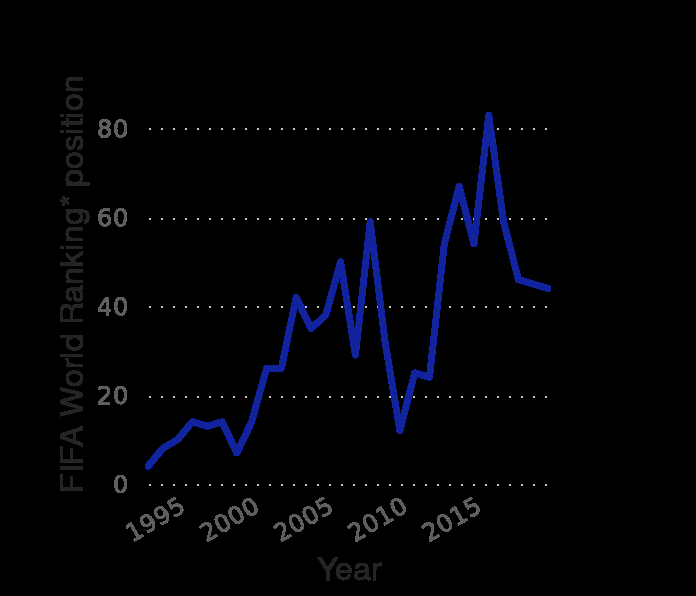<image>
In which year did the Norwegian national team show improvement in their ranking? The Norwegian national team showed improvement in their ranking over time, but the specific year is not mentioned in the description. What is the range of the y-axis in the line graph? The range of the y-axis in the line graph is from 0 to 80. What is the time period covered by the line graph? The time period covered by the line graph is from 1995 to 2015. 